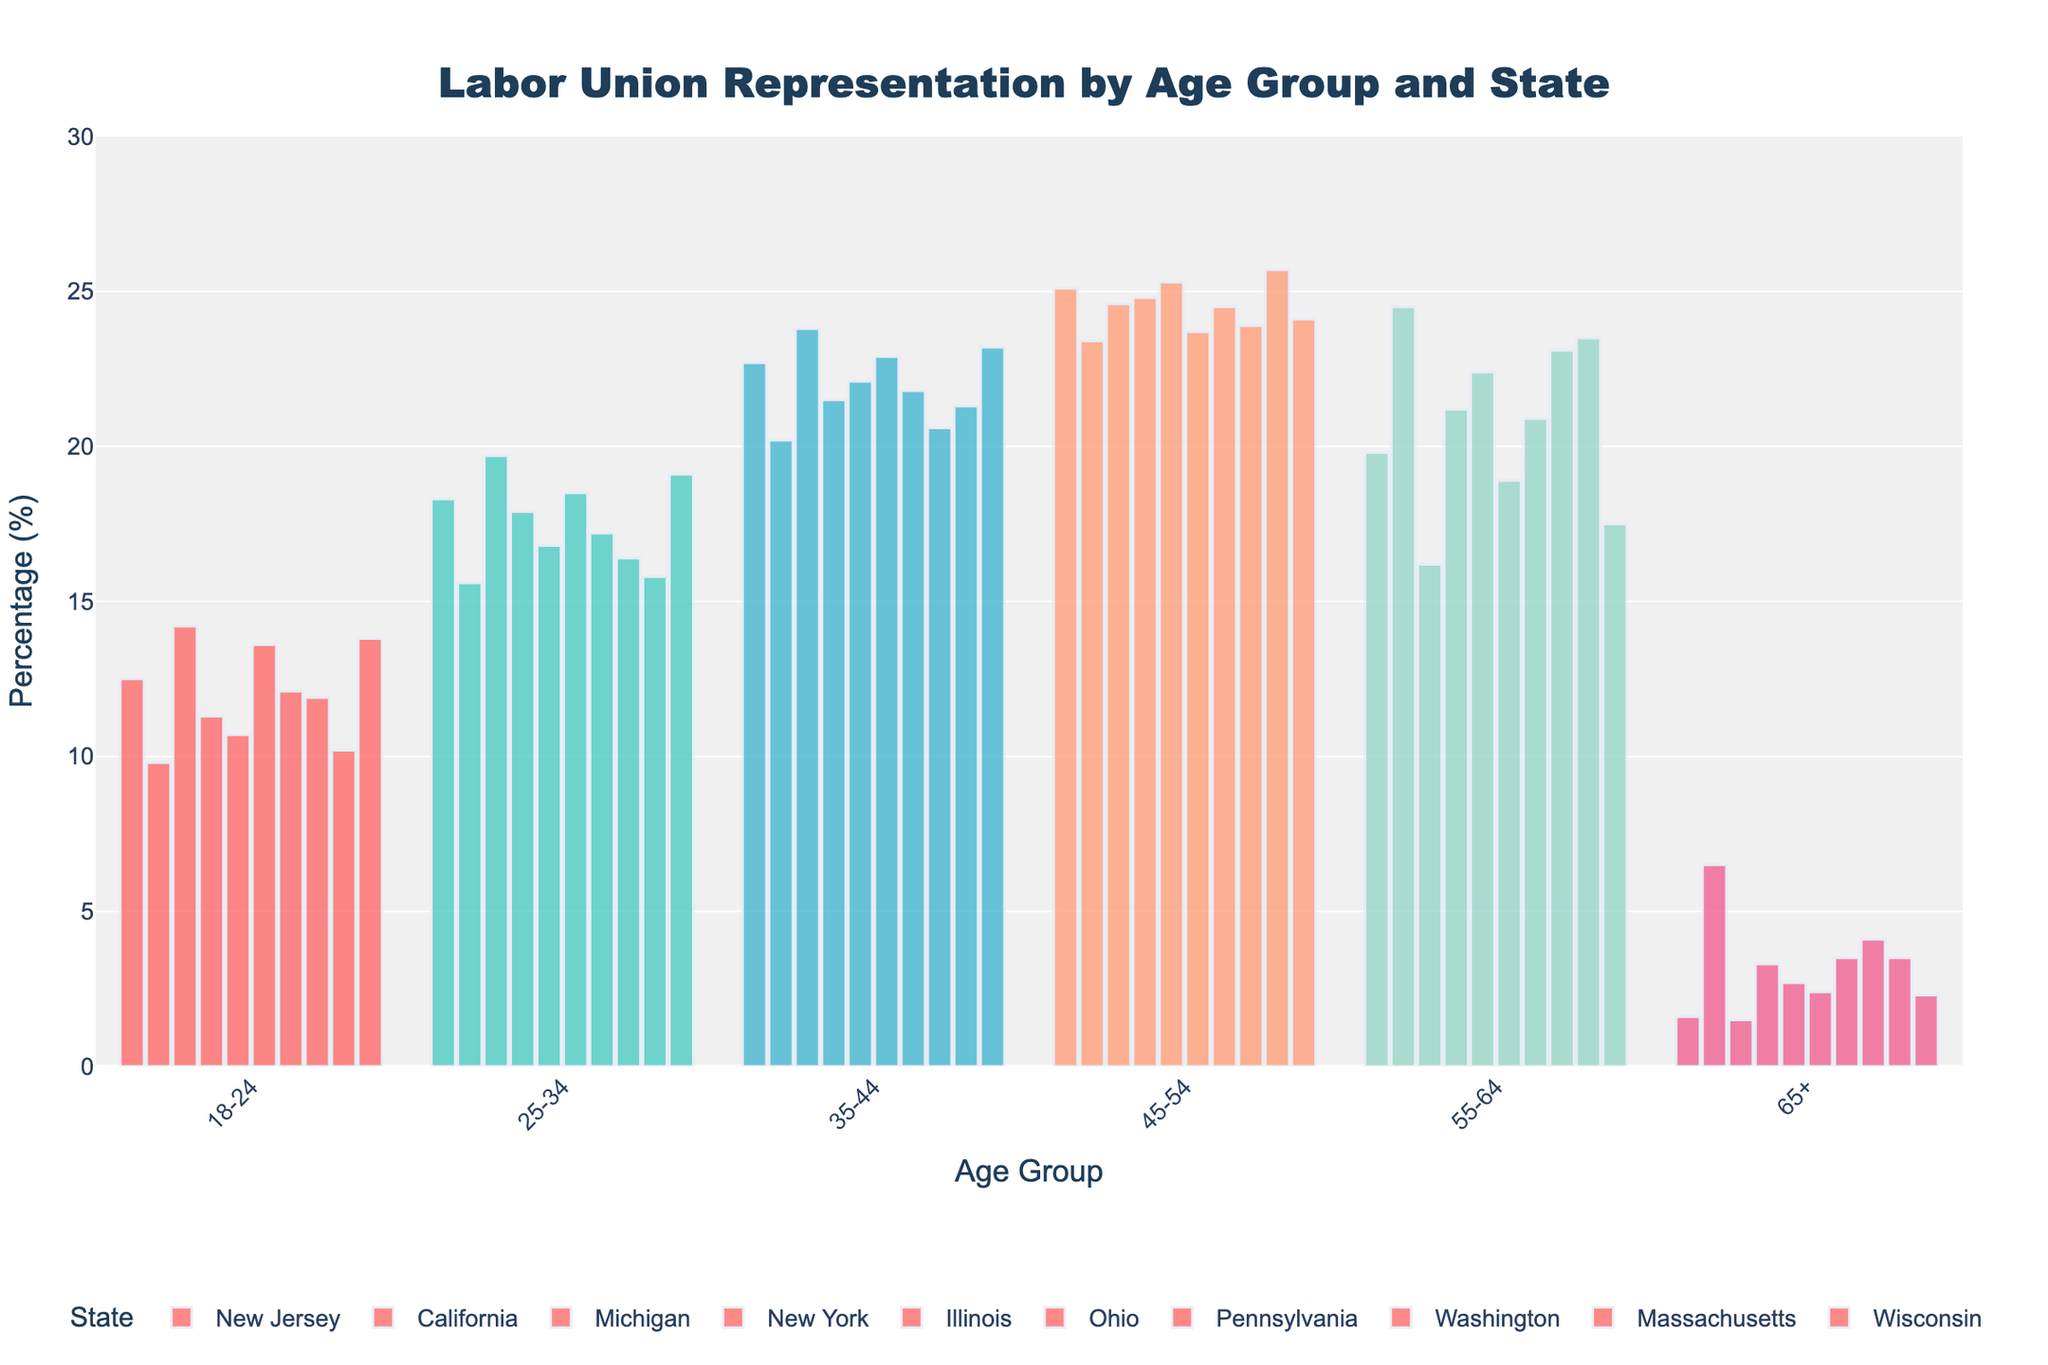Which age group has the highest labor union representation percentage in Michigan? By looking at the various age group bars for Michigan, we see the highest percentage value is for the 45-54 age group with 24.6%.
Answer: 45-54 Which state has the lowest representation in the 65+ age group? By comparing the 65+ percentage values for all the states, New Jersey has the lowest representation with 1.6%.
Answer: New Jersey What is the difference in union representation between the 35-44 and 55-64 age groups in California? The union representation in the 35-44 age group for California is 20.2%, and for 55-64 it is 24.5%. The difference is 24.5 - 20.2 = 4.3%.
Answer: 4.3% Which state has the most uniform distribution of labor union representation across all age groups? By visually examining the bar heights for each age group in each state, Ohio's representation looks fairly even across all age groups without extreme skew.
Answer: Ohio What is the average union representation for the 25-34 age group across all states? The values for the 25-34 age group are: 18.3, 15.6, 19.7, 17.9, 16.8, 18.5, 17.2, 16.4, 15.8, and 19.1. Adding these: 175.3. Dividing by 10 states gives: 175.3 / 10 = 17.53%.
Answer: 17.53% Compare the representation in the 45-54 age group between New York and Massachusetts, and identify which state has higher representation. The 45-54 age group in New York has 24.8% representation, while in Massachusetts it is 25.7%. Massachusetts has higher representation with 25.7%.
Answer: Massachusetts Which state shows the second highest representation in the 55-64 age group? By ordering the 55-64 percentages, the highest is California (24.5%), and second highest is Massachusetts with 23.5%.
Answer: Massachusetts How does Illinois compare to Washington in labor union representation for the 35-44 age group? Illinois has 22.1% representation for the 35-44 age group, while Washington has 20.6%. Illinois has higher representation.
Answer: Illinois What is the sum of the union representation percentages for all age groups in New Jersey? The percentages for all age groups in New Jersey are 12.5, 18.3, 22.7, 25.1, 19.8, and 1.6. Summing these: 12.5 + 18.3 + 22.7 + 25.1 + 19.8 + 1.6 = 100%.
Answer: 100% 